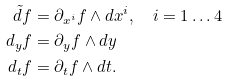Convert formula to latex. <formula><loc_0><loc_0><loc_500><loc_500>\tilde { d } f & = \partial _ { x ^ { i } } f \wedge d x ^ { i } , \quad i = 1 \dots 4 \\ d _ { y } f & = \partial _ { y } f \wedge d y \\ d _ { t } f & = \partial _ { t } f \wedge d t .</formula> 